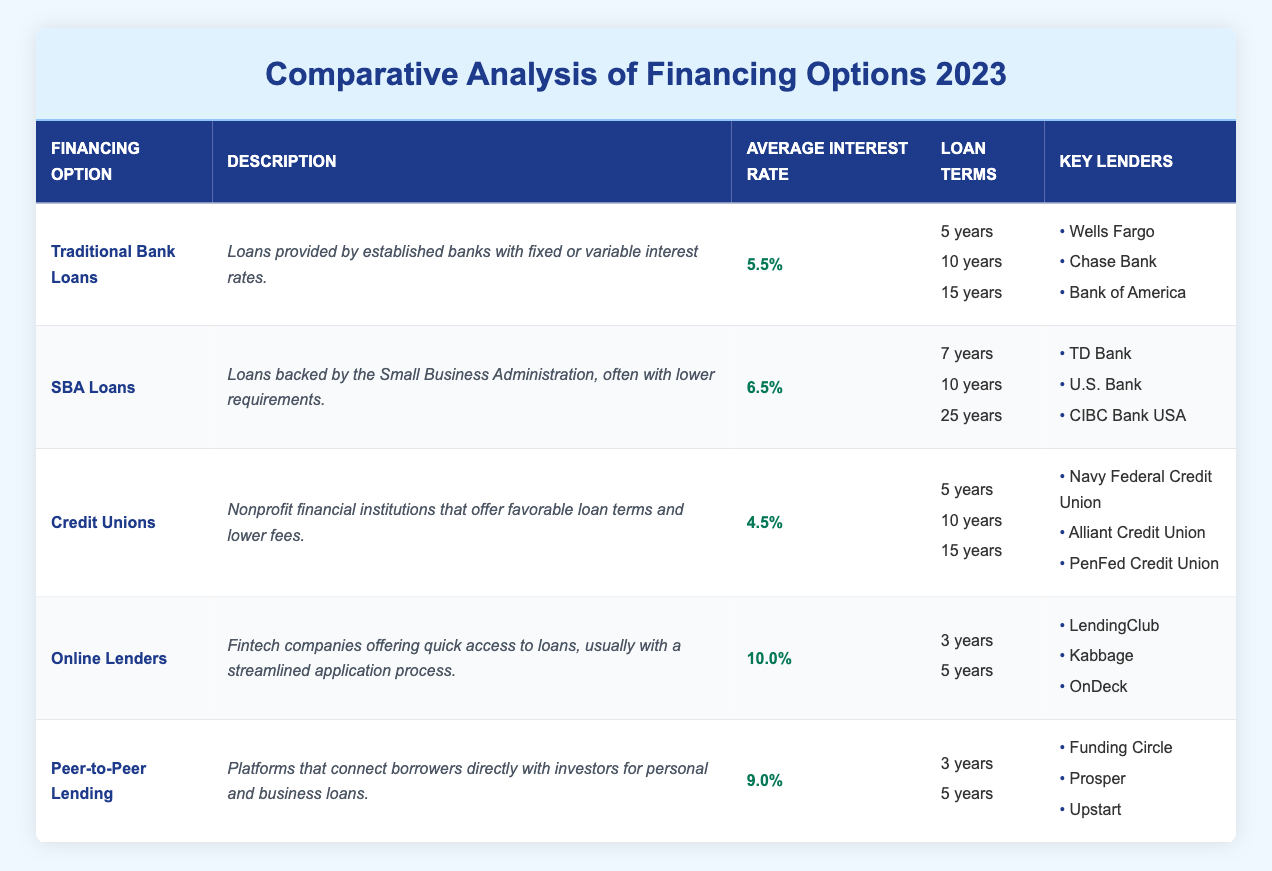What is the average interest rate of Traditional Bank Loans? The table indicates that the average interest rate for Traditional Bank Loans is listed specifically as 5.5%.
Answer: 5.5% Which financing option has the lowest average interest rate? By looking at the average interest rates provided, Credit Unions have the lowest rate at 4.5%.
Answer: 4.5% What are the loan terms available for SBA Loans? The table lists the loan terms for SBA Loans as 7 years, 10 years, and 25 years.
Answer: 7 years, 10 years, 25 years Is the average interest rate for Online Lenders higher than that for Credit Unions? The average interest rate for Online Lenders is 10.0%, while for Credit Unions it is 4.5%. Therefore, 10.0% is indeed higher than 4.5%.
Answer: Yes What is the difference between the highest and lowest average interest rates among the financing options? The highest average interest rate is 10.0% (Online Lenders), and the lowest is 4.5% (Credit Unions). The difference is calculated as 10.0% - 4.5% = 5.5%.
Answer: 5.5% Which financing option provides the longest loan term, and what is that term? The SBA Loans option offers the longest loan term of 25 years, as seen in the loan terms listed for it.
Answer: 25 years (SBA Loans) Are there any financing options that offer a loan term of 3 years? Upon reviewing the loan terms, both Online Lenders and Peer-to-Peer Lending provide loan terms of 3 years.
Answer: Yes What is the average interest rate for Peer-to-Peer Lending? The table shows that the average interest rate for Peer-to-Peer Lending is 9.0%.
Answer: 9.0% How many key lenders are listed for Credit Unions? The table lists three key lenders under Credit Unions: Navy Federal Credit Union, Alliant Credit Union, and PenFed Credit Union.
Answer: 3 